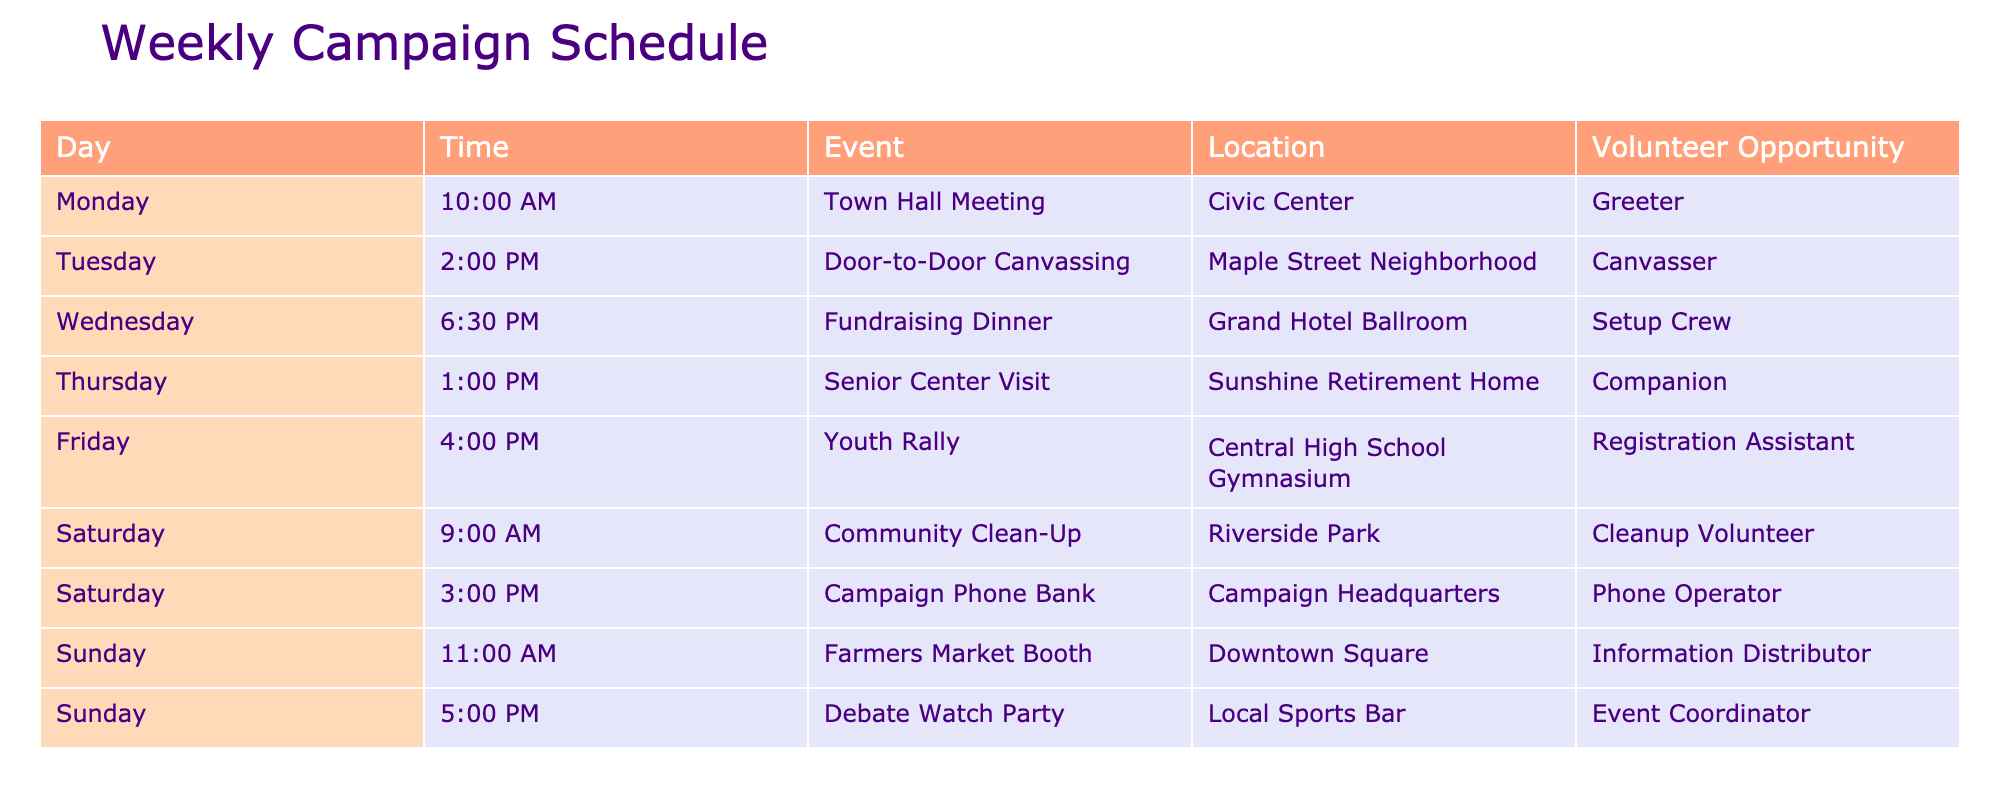What time is the Town Hall Meeting scheduled? The Town Hall Meeting is listed in the table under Monday at 10:00 AM. This information can be retrieved directly from the "Time" column corresponding to the event "Town Hall Meeting."
Answer: 10:00 AM Which event takes place on Saturday at 3:00 PM? According to the table, the event scheduled for Saturday at 3:00 PM is the Campaign Phone Bank. This can be found by locating the row in the table that matches both the day (Saturday) and the time (3:00 PM).
Answer: Campaign Phone Bank How many events are scheduled on Sunday? The table lists two events on Sunday: the Farmers Market Booth at 11:00 AM and the Debate Watch Party at 5:00 PM. Thus, we count the rows that fall under the day "Sunday" to arrive at the number of events.
Answer: 2 What is the volunteer opportunity for the Community Clean-Up? The Community Clean-Up event is associated with the volunteer opportunity titled "Cleanup Volunteer," which can be directly found by looking at the "Volunteer Opportunity" column for the corresponding event listed on Saturday at 9:00 AM.
Answer: Cleanup Volunteer Is there a Fundraising Dinner scheduled for Friday? The table indicates that the Fundraising Dinner takes place on Wednesday at 6:30 PM, and there is no event by that name listed for Friday. By checking the events occurring on Friday, we see that a Youth Rally is noted instead.
Answer: No What is the average time of the events scheduled on Saturday? The events scheduled on Saturday include the Community Clean-Up at 9:00 AM and the Campaign Phone Bank at 3:00 PM. To find the average, convert these times to 24-hour format (9:00 AM is 09:00 and 3:00 PM is 15:00), calculate the total (9 + 15 = 24), and divide by the number of events (2). Thus, the average time is 24/2 = 12.
Answer: 12:00 PM How many unique locations are mentioned in the table? The locations listed include Civic Center, Maple Street Neighborhood, Grand Hotel Ballroom, Sunshine Retirement Home, Central High School Gymnasium, Riverside Park, Campaign Headquarters, Downtown Square, and Local Sports Bar. By counting each unique location without repetition, we arrive at a total of 9 locations.
Answer: 9 Which event has the longest duration from the start to end of the day? To find the longest duration, we look at the events. The events span from 9:00 AM (Community Clean-Up) to 5:00 PM (Debate Watch Party) on Sunday. This gives us the time difference from 9:00 AM to 5:00 PM, a total of 8 hours. The maximum duration in the context of events is taken from the last event scheduled.
Answer: Debate Watch Party at 5:00 PM What is the total number of volunteer opportunities available throughout the week? By counting the hobby roles listed in the "Volunteer Opportunity" column, we find a total of 9 unique volunteer opportunities associated with each event in the week. This can be obtained by tallying each entry representing volunteer roles for the listed events.
Answer: 9 